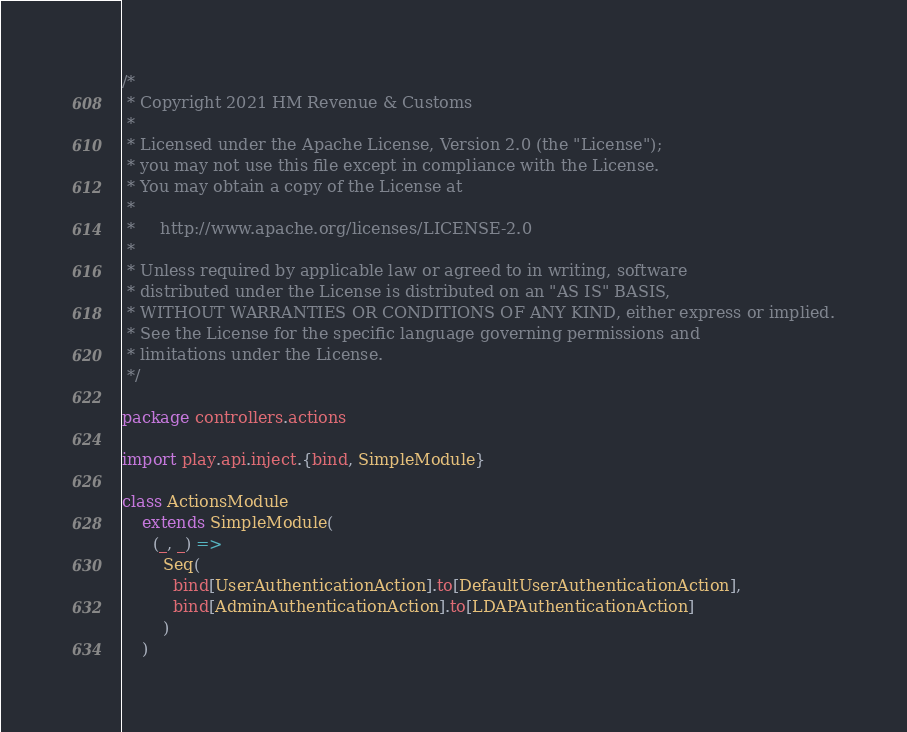Convert code to text. <code><loc_0><loc_0><loc_500><loc_500><_Scala_>/*
 * Copyright 2021 HM Revenue & Customs
 *
 * Licensed under the Apache License, Version 2.0 (the "License");
 * you may not use this file except in compliance with the License.
 * You may obtain a copy of the License at
 *
 *     http://www.apache.org/licenses/LICENSE-2.0
 *
 * Unless required by applicable law or agreed to in writing, software
 * distributed under the License is distributed on an "AS IS" BASIS,
 * WITHOUT WARRANTIES OR CONDITIONS OF ANY KIND, either express or implied.
 * See the License for the specific language governing permissions and
 * limitations under the License.
 */

package controllers.actions

import play.api.inject.{bind, SimpleModule}

class ActionsModule
    extends SimpleModule(
      (_, _) =>
        Seq(
          bind[UserAuthenticationAction].to[DefaultUserAuthenticationAction],
          bind[AdminAuthenticationAction].to[LDAPAuthenticationAction]
        )
    )
</code> 